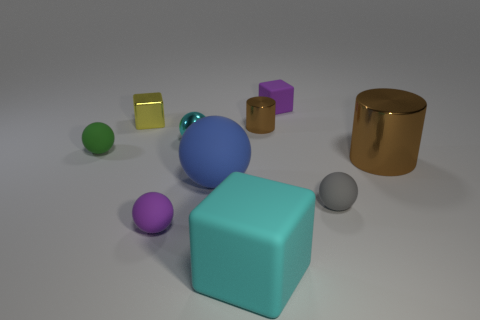There is a small purple thing left of the cyan shiny sphere; what material is it?
Provide a short and direct response. Rubber. Are there fewer small gray matte balls than small purple things?
Offer a very short reply. Yes. There is a small brown metallic object; does it have the same shape as the large thing that is behind the blue ball?
Your response must be concise. Yes. There is a small matte object that is both left of the big matte cube and to the right of the green sphere; what shape is it?
Keep it short and to the point. Sphere. Is the number of small rubber things that are to the right of the metallic ball the same as the number of small gray balls that are right of the large metal thing?
Make the answer very short. No. Is the shape of the purple matte thing behind the small yellow metallic block the same as  the small yellow object?
Your answer should be very brief. Yes. What number of red things are big shiny cylinders or balls?
Offer a terse response. 0. There is a small green object that is the same shape as the gray object; what is it made of?
Make the answer very short. Rubber. What is the shape of the purple object behind the tiny green sphere?
Give a very brief answer. Cube. Is there a tiny purple object made of the same material as the small green thing?
Make the answer very short. Yes. 